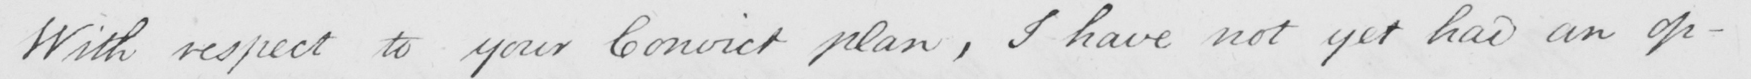What text is written in this handwritten line? With respect to your Convict plan , I have not yet had an op- 